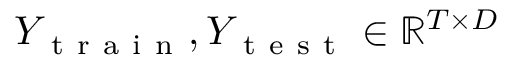Convert formula to latex. <formula><loc_0><loc_0><loc_500><loc_500>Y _ { t r a i n } , Y _ { t e s t } \in \mathbb { R } ^ { T \times D }</formula> 